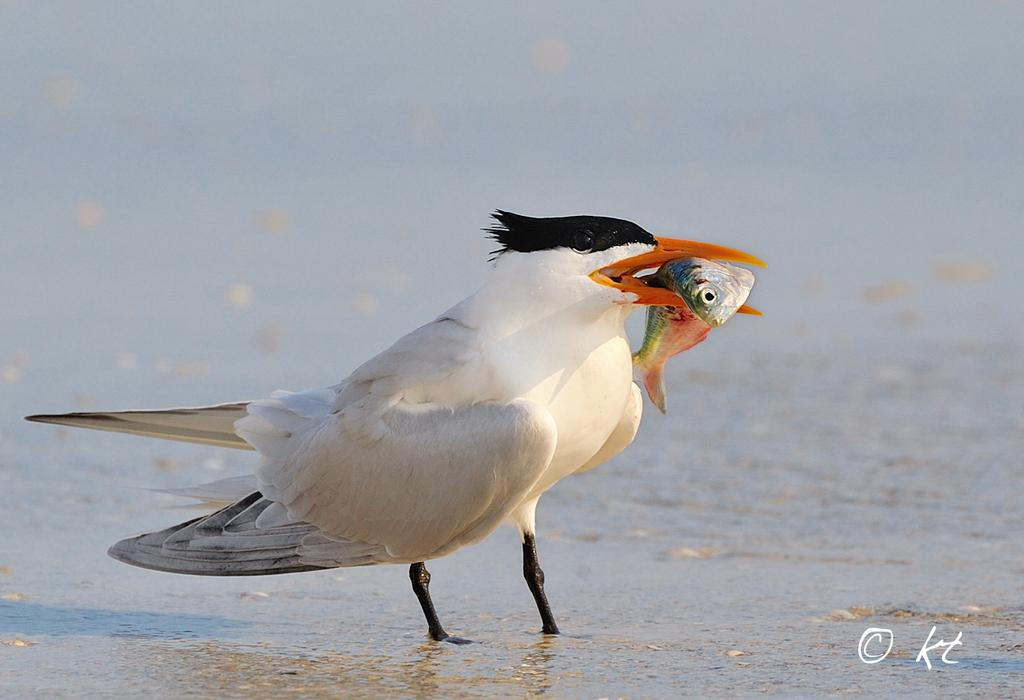What animal can be seen in the image? There is a bird in the image. What is the bird doing in the image? The bird is holding a fish in its mouth. What can be seen in the background of the image? There is a river in the background of the image. What type of stamp can be seen on the bird's wing in the image? There is no stamp visible on the bird's wing in the image. What drink is the bird holding in its other claw in the image? The bird is not holding a drink in the image; it is holding a fish in its mouth. 